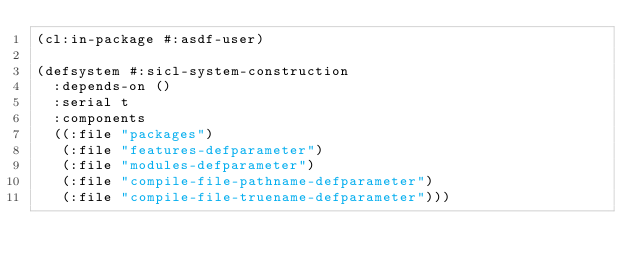Convert code to text. <code><loc_0><loc_0><loc_500><loc_500><_Lisp_>(cl:in-package #:asdf-user)

(defsystem #:sicl-system-construction
  :depends-on ()
  :serial t
  :components
  ((:file "packages")
   (:file "features-defparameter")
   (:file "modules-defparameter")
   (:file "compile-file-pathname-defparameter")
   (:file "compile-file-truename-defparameter")))
</code> 